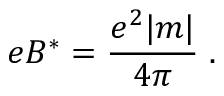<formula> <loc_0><loc_0><loc_500><loc_500>e B ^ { * } = \frac { e ^ { 2 } | m | } { 4 \pi } \, .</formula> 